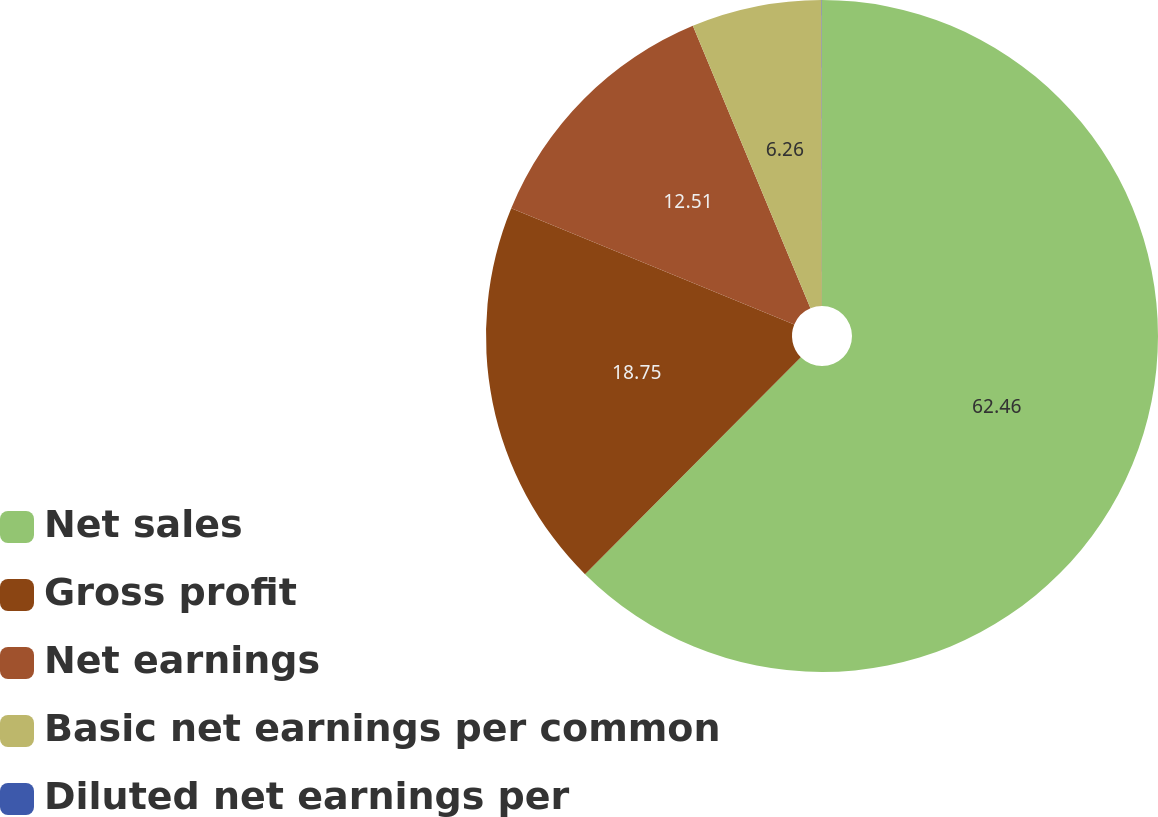Convert chart to OTSL. <chart><loc_0><loc_0><loc_500><loc_500><pie_chart><fcel>Net sales<fcel>Gross profit<fcel>Net earnings<fcel>Basic net earnings per common<fcel>Diluted net earnings per<nl><fcel>62.46%<fcel>18.75%<fcel>12.51%<fcel>6.26%<fcel>0.02%<nl></chart> 